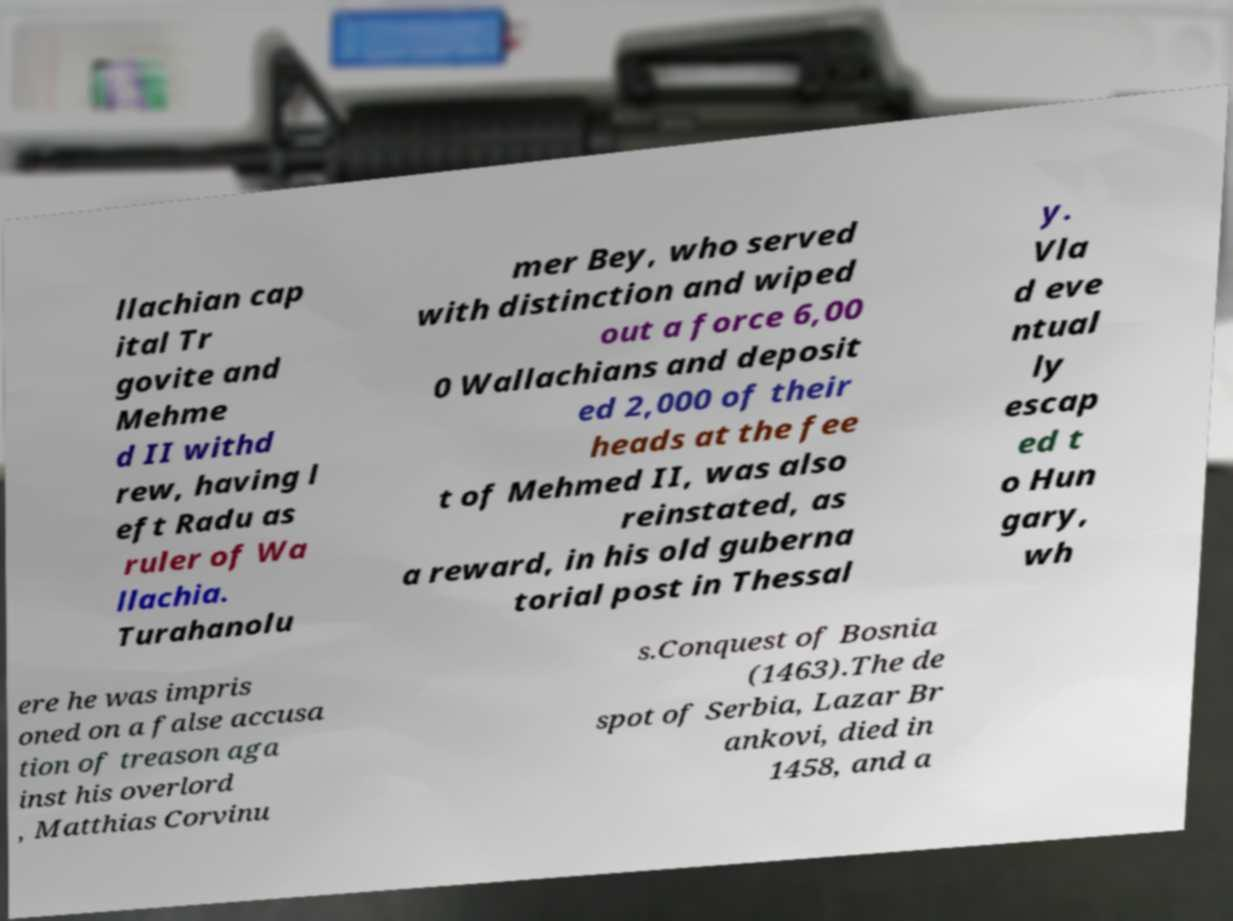There's text embedded in this image that I need extracted. Can you transcribe it verbatim? llachian cap ital Tr govite and Mehme d II withd rew, having l eft Radu as ruler of Wa llachia. Turahanolu mer Bey, who served with distinction and wiped out a force 6,00 0 Wallachians and deposit ed 2,000 of their heads at the fee t of Mehmed II, was also reinstated, as a reward, in his old guberna torial post in Thessal y. Vla d eve ntual ly escap ed t o Hun gary, wh ere he was impris oned on a false accusa tion of treason aga inst his overlord , Matthias Corvinu s.Conquest of Bosnia (1463).The de spot of Serbia, Lazar Br ankovi, died in 1458, and a 